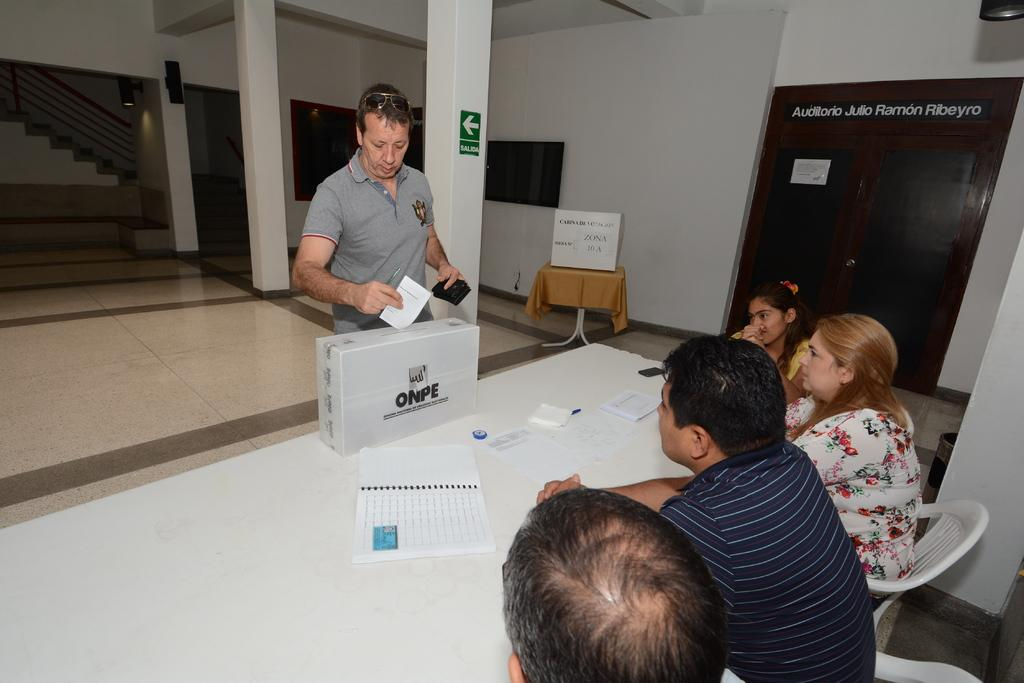What are the people in the image doing? The people in the image are seated on chairs. What action is the man performing in the image? The man is dropping paper into a box. What objects can be seen on the table in the image? There is a book and papers on the table. What type of nut is being used to hold the book open on the table? There is no nut present in the image, and the book is not being held open. 